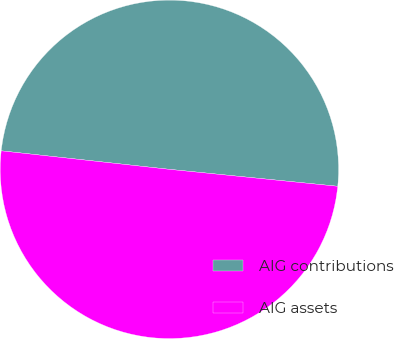<chart> <loc_0><loc_0><loc_500><loc_500><pie_chart><fcel>AIG contributions<fcel>AIG assets<nl><fcel>49.85%<fcel>50.15%<nl></chart> 